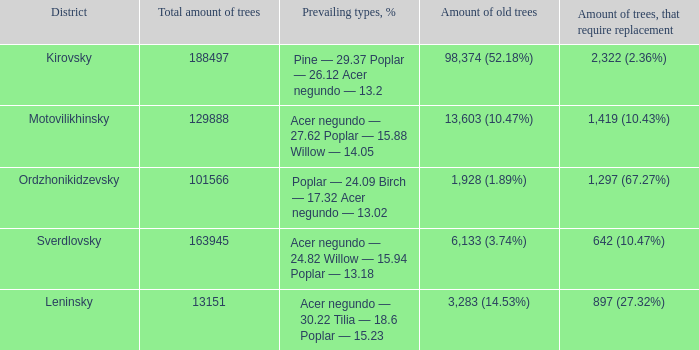What is the total number of trees in the leninsky region? 13151.0. 